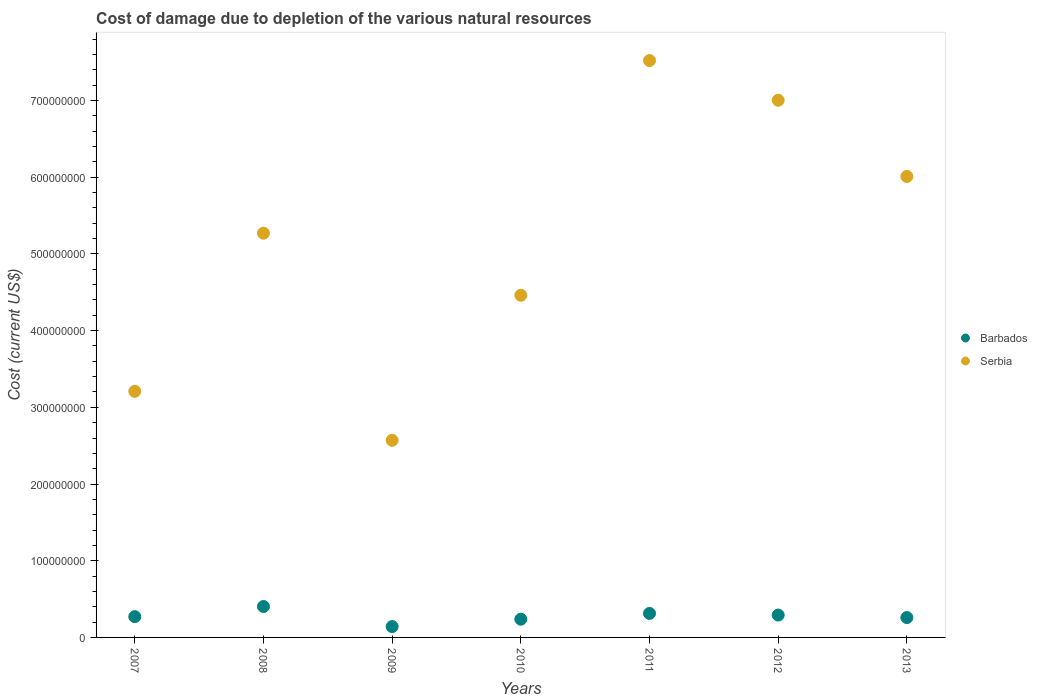How many different coloured dotlines are there?
Ensure brevity in your answer.  2. Is the number of dotlines equal to the number of legend labels?
Offer a very short reply. Yes. What is the cost of damage caused due to the depletion of various natural resources in Serbia in 2011?
Make the answer very short. 7.52e+08. Across all years, what is the maximum cost of damage caused due to the depletion of various natural resources in Serbia?
Your response must be concise. 7.52e+08. Across all years, what is the minimum cost of damage caused due to the depletion of various natural resources in Serbia?
Make the answer very short. 2.57e+08. In which year was the cost of damage caused due to the depletion of various natural resources in Barbados maximum?
Offer a very short reply. 2008. What is the total cost of damage caused due to the depletion of various natural resources in Barbados in the graph?
Your response must be concise. 1.92e+08. What is the difference between the cost of damage caused due to the depletion of various natural resources in Serbia in 2008 and that in 2009?
Give a very brief answer. 2.70e+08. What is the difference between the cost of damage caused due to the depletion of various natural resources in Serbia in 2010 and the cost of damage caused due to the depletion of various natural resources in Barbados in 2007?
Offer a very short reply. 4.19e+08. What is the average cost of damage caused due to the depletion of various natural resources in Serbia per year?
Your response must be concise. 5.15e+08. In the year 2009, what is the difference between the cost of damage caused due to the depletion of various natural resources in Barbados and cost of damage caused due to the depletion of various natural resources in Serbia?
Give a very brief answer. -2.43e+08. What is the ratio of the cost of damage caused due to the depletion of various natural resources in Barbados in 2008 to that in 2009?
Your response must be concise. 2.85. Is the cost of damage caused due to the depletion of various natural resources in Serbia in 2011 less than that in 2013?
Offer a very short reply. No. What is the difference between the highest and the second highest cost of damage caused due to the depletion of various natural resources in Serbia?
Make the answer very short. 5.17e+07. What is the difference between the highest and the lowest cost of damage caused due to the depletion of various natural resources in Serbia?
Your answer should be very brief. 4.95e+08. Is the sum of the cost of damage caused due to the depletion of various natural resources in Serbia in 2009 and 2010 greater than the maximum cost of damage caused due to the depletion of various natural resources in Barbados across all years?
Make the answer very short. Yes. Does the cost of damage caused due to the depletion of various natural resources in Barbados monotonically increase over the years?
Keep it short and to the point. No. Is the cost of damage caused due to the depletion of various natural resources in Serbia strictly less than the cost of damage caused due to the depletion of various natural resources in Barbados over the years?
Ensure brevity in your answer.  No. What is the difference between two consecutive major ticks on the Y-axis?
Offer a very short reply. 1.00e+08. Are the values on the major ticks of Y-axis written in scientific E-notation?
Make the answer very short. No. Where does the legend appear in the graph?
Keep it short and to the point. Center right. How many legend labels are there?
Keep it short and to the point. 2. What is the title of the graph?
Give a very brief answer. Cost of damage due to depletion of the various natural resources. What is the label or title of the Y-axis?
Provide a short and direct response. Cost (current US$). What is the Cost (current US$) in Barbados in 2007?
Offer a very short reply. 2.71e+07. What is the Cost (current US$) in Serbia in 2007?
Make the answer very short. 3.21e+08. What is the Cost (current US$) in Barbados in 2008?
Your answer should be compact. 4.03e+07. What is the Cost (current US$) in Serbia in 2008?
Offer a very short reply. 5.27e+08. What is the Cost (current US$) in Barbados in 2009?
Provide a short and direct response. 1.41e+07. What is the Cost (current US$) in Serbia in 2009?
Offer a terse response. 2.57e+08. What is the Cost (current US$) of Barbados in 2010?
Your answer should be very brief. 2.38e+07. What is the Cost (current US$) in Serbia in 2010?
Offer a terse response. 4.46e+08. What is the Cost (current US$) of Barbados in 2011?
Make the answer very short. 3.13e+07. What is the Cost (current US$) of Serbia in 2011?
Make the answer very short. 7.52e+08. What is the Cost (current US$) of Barbados in 2012?
Your response must be concise. 2.92e+07. What is the Cost (current US$) of Serbia in 2012?
Offer a terse response. 7.00e+08. What is the Cost (current US$) of Barbados in 2013?
Provide a succinct answer. 2.59e+07. What is the Cost (current US$) in Serbia in 2013?
Provide a short and direct response. 6.01e+08. Across all years, what is the maximum Cost (current US$) in Barbados?
Your answer should be compact. 4.03e+07. Across all years, what is the maximum Cost (current US$) in Serbia?
Keep it short and to the point. 7.52e+08. Across all years, what is the minimum Cost (current US$) of Barbados?
Your answer should be compact. 1.41e+07. Across all years, what is the minimum Cost (current US$) in Serbia?
Your response must be concise. 2.57e+08. What is the total Cost (current US$) in Barbados in the graph?
Keep it short and to the point. 1.92e+08. What is the total Cost (current US$) in Serbia in the graph?
Your answer should be very brief. 3.60e+09. What is the difference between the Cost (current US$) of Barbados in 2007 and that in 2008?
Offer a terse response. -1.32e+07. What is the difference between the Cost (current US$) in Serbia in 2007 and that in 2008?
Offer a terse response. -2.06e+08. What is the difference between the Cost (current US$) of Barbados in 2007 and that in 2009?
Your response must be concise. 1.30e+07. What is the difference between the Cost (current US$) in Serbia in 2007 and that in 2009?
Ensure brevity in your answer.  6.39e+07. What is the difference between the Cost (current US$) in Barbados in 2007 and that in 2010?
Offer a terse response. 3.32e+06. What is the difference between the Cost (current US$) of Serbia in 2007 and that in 2010?
Your response must be concise. -1.25e+08. What is the difference between the Cost (current US$) in Barbados in 2007 and that in 2011?
Provide a short and direct response. -4.22e+06. What is the difference between the Cost (current US$) of Serbia in 2007 and that in 2011?
Keep it short and to the point. -4.31e+08. What is the difference between the Cost (current US$) in Barbados in 2007 and that in 2012?
Ensure brevity in your answer.  -2.08e+06. What is the difference between the Cost (current US$) of Serbia in 2007 and that in 2012?
Your response must be concise. -3.80e+08. What is the difference between the Cost (current US$) of Barbados in 2007 and that in 2013?
Offer a very short reply. 1.18e+06. What is the difference between the Cost (current US$) of Serbia in 2007 and that in 2013?
Provide a succinct answer. -2.80e+08. What is the difference between the Cost (current US$) of Barbados in 2008 and that in 2009?
Your answer should be very brief. 2.62e+07. What is the difference between the Cost (current US$) in Serbia in 2008 and that in 2009?
Your answer should be compact. 2.70e+08. What is the difference between the Cost (current US$) in Barbados in 2008 and that in 2010?
Provide a succinct answer. 1.66e+07. What is the difference between the Cost (current US$) in Serbia in 2008 and that in 2010?
Make the answer very short. 8.09e+07. What is the difference between the Cost (current US$) of Barbados in 2008 and that in 2011?
Your response must be concise. 9.01e+06. What is the difference between the Cost (current US$) of Serbia in 2008 and that in 2011?
Your answer should be very brief. -2.25e+08. What is the difference between the Cost (current US$) of Barbados in 2008 and that in 2012?
Your answer should be compact. 1.12e+07. What is the difference between the Cost (current US$) of Serbia in 2008 and that in 2012?
Give a very brief answer. -1.73e+08. What is the difference between the Cost (current US$) in Barbados in 2008 and that in 2013?
Provide a succinct answer. 1.44e+07. What is the difference between the Cost (current US$) of Serbia in 2008 and that in 2013?
Give a very brief answer. -7.40e+07. What is the difference between the Cost (current US$) of Barbados in 2009 and that in 2010?
Make the answer very short. -9.64e+06. What is the difference between the Cost (current US$) of Serbia in 2009 and that in 2010?
Your answer should be compact. -1.89e+08. What is the difference between the Cost (current US$) of Barbados in 2009 and that in 2011?
Offer a very short reply. -1.72e+07. What is the difference between the Cost (current US$) in Serbia in 2009 and that in 2011?
Your answer should be compact. -4.95e+08. What is the difference between the Cost (current US$) of Barbados in 2009 and that in 2012?
Your response must be concise. -1.50e+07. What is the difference between the Cost (current US$) of Serbia in 2009 and that in 2012?
Your answer should be compact. -4.43e+08. What is the difference between the Cost (current US$) in Barbados in 2009 and that in 2013?
Offer a very short reply. -1.18e+07. What is the difference between the Cost (current US$) of Serbia in 2009 and that in 2013?
Your answer should be compact. -3.44e+08. What is the difference between the Cost (current US$) of Barbados in 2010 and that in 2011?
Offer a very short reply. -7.55e+06. What is the difference between the Cost (current US$) of Serbia in 2010 and that in 2011?
Provide a succinct answer. -3.06e+08. What is the difference between the Cost (current US$) of Barbados in 2010 and that in 2012?
Make the answer very short. -5.40e+06. What is the difference between the Cost (current US$) of Serbia in 2010 and that in 2012?
Provide a short and direct response. -2.54e+08. What is the difference between the Cost (current US$) in Barbados in 2010 and that in 2013?
Your answer should be very brief. -2.14e+06. What is the difference between the Cost (current US$) of Serbia in 2010 and that in 2013?
Ensure brevity in your answer.  -1.55e+08. What is the difference between the Cost (current US$) in Barbados in 2011 and that in 2012?
Your response must be concise. 2.15e+06. What is the difference between the Cost (current US$) of Serbia in 2011 and that in 2012?
Offer a very short reply. 5.17e+07. What is the difference between the Cost (current US$) in Barbados in 2011 and that in 2013?
Ensure brevity in your answer.  5.41e+06. What is the difference between the Cost (current US$) in Serbia in 2011 and that in 2013?
Offer a terse response. 1.51e+08. What is the difference between the Cost (current US$) of Barbados in 2012 and that in 2013?
Give a very brief answer. 3.26e+06. What is the difference between the Cost (current US$) of Serbia in 2012 and that in 2013?
Offer a terse response. 9.94e+07. What is the difference between the Cost (current US$) in Barbados in 2007 and the Cost (current US$) in Serbia in 2008?
Your answer should be compact. -5.00e+08. What is the difference between the Cost (current US$) in Barbados in 2007 and the Cost (current US$) in Serbia in 2009?
Keep it short and to the point. -2.30e+08. What is the difference between the Cost (current US$) in Barbados in 2007 and the Cost (current US$) in Serbia in 2010?
Offer a terse response. -4.19e+08. What is the difference between the Cost (current US$) in Barbados in 2007 and the Cost (current US$) in Serbia in 2011?
Provide a succinct answer. -7.25e+08. What is the difference between the Cost (current US$) of Barbados in 2007 and the Cost (current US$) of Serbia in 2012?
Make the answer very short. -6.73e+08. What is the difference between the Cost (current US$) in Barbados in 2007 and the Cost (current US$) in Serbia in 2013?
Give a very brief answer. -5.74e+08. What is the difference between the Cost (current US$) in Barbados in 2008 and the Cost (current US$) in Serbia in 2009?
Offer a very short reply. -2.17e+08. What is the difference between the Cost (current US$) in Barbados in 2008 and the Cost (current US$) in Serbia in 2010?
Provide a succinct answer. -4.06e+08. What is the difference between the Cost (current US$) of Barbados in 2008 and the Cost (current US$) of Serbia in 2011?
Offer a terse response. -7.12e+08. What is the difference between the Cost (current US$) in Barbados in 2008 and the Cost (current US$) in Serbia in 2012?
Ensure brevity in your answer.  -6.60e+08. What is the difference between the Cost (current US$) in Barbados in 2008 and the Cost (current US$) in Serbia in 2013?
Your answer should be very brief. -5.61e+08. What is the difference between the Cost (current US$) of Barbados in 2009 and the Cost (current US$) of Serbia in 2010?
Offer a terse response. -4.32e+08. What is the difference between the Cost (current US$) in Barbados in 2009 and the Cost (current US$) in Serbia in 2011?
Your answer should be very brief. -7.38e+08. What is the difference between the Cost (current US$) in Barbados in 2009 and the Cost (current US$) in Serbia in 2012?
Make the answer very short. -6.86e+08. What is the difference between the Cost (current US$) of Barbados in 2009 and the Cost (current US$) of Serbia in 2013?
Offer a terse response. -5.87e+08. What is the difference between the Cost (current US$) in Barbados in 2010 and the Cost (current US$) in Serbia in 2011?
Your answer should be very brief. -7.28e+08. What is the difference between the Cost (current US$) of Barbados in 2010 and the Cost (current US$) of Serbia in 2012?
Your response must be concise. -6.77e+08. What is the difference between the Cost (current US$) in Barbados in 2010 and the Cost (current US$) in Serbia in 2013?
Provide a short and direct response. -5.77e+08. What is the difference between the Cost (current US$) of Barbados in 2011 and the Cost (current US$) of Serbia in 2012?
Offer a very short reply. -6.69e+08. What is the difference between the Cost (current US$) in Barbados in 2011 and the Cost (current US$) in Serbia in 2013?
Give a very brief answer. -5.70e+08. What is the difference between the Cost (current US$) in Barbados in 2012 and the Cost (current US$) in Serbia in 2013?
Offer a very short reply. -5.72e+08. What is the average Cost (current US$) of Barbados per year?
Your response must be concise. 2.74e+07. What is the average Cost (current US$) of Serbia per year?
Keep it short and to the point. 5.15e+08. In the year 2007, what is the difference between the Cost (current US$) in Barbados and Cost (current US$) in Serbia?
Your response must be concise. -2.94e+08. In the year 2008, what is the difference between the Cost (current US$) of Barbados and Cost (current US$) of Serbia?
Make the answer very short. -4.87e+08. In the year 2009, what is the difference between the Cost (current US$) in Barbados and Cost (current US$) in Serbia?
Provide a succinct answer. -2.43e+08. In the year 2010, what is the difference between the Cost (current US$) of Barbados and Cost (current US$) of Serbia?
Your answer should be very brief. -4.22e+08. In the year 2011, what is the difference between the Cost (current US$) of Barbados and Cost (current US$) of Serbia?
Your answer should be very brief. -7.21e+08. In the year 2012, what is the difference between the Cost (current US$) of Barbados and Cost (current US$) of Serbia?
Your answer should be compact. -6.71e+08. In the year 2013, what is the difference between the Cost (current US$) in Barbados and Cost (current US$) in Serbia?
Offer a very short reply. -5.75e+08. What is the ratio of the Cost (current US$) of Barbados in 2007 to that in 2008?
Your answer should be very brief. 0.67. What is the ratio of the Cost (current US$) of Serbia in 2007 to that in 2008?
Ensure brevity in your answer.  0.61. What is the ratio of the Cost (current US$) of Barbados in 2007 to that in 2009?
Keep it short and to the point. 1.92. What is the ratio of the Cost (current US$) of Serbia in 2007 to that in 2009?
Give a very brief answer. 1.25. What is the ratio of the Cost (current US$) of Barbados in 2007 to that in 2010?
Ensure brevity in your answer.  1.14. What is the ratio of the Cost (current US$) of Serbia in 2007 to that in 2010?
Your answer should be very brief. 0.72. What is the ratio of the Cost (current US$) of Barbados in 2007 to that in 2011?
Make the answer very short. 0.87. What is the ratio of the Cost (current US$) in Serbia in 2007 to that in 2011?
Offer a terse response. 0.43. What is the ratio of the Cost (current US$) of Barbados in 2007 to that in 2012?
Make the answer very short. 0.93. What is the ratio of the Cost (current US$) of Serbia in 2007 to that in 2012?
Provide a short and direct response. 0.46. What is the ratio of the Cost (current US$) in Barbados in 2007 to that in 2013?
Your answer should be very brief. 1.05. What is the ratio of the Cost (current US$) in Serbia in 2007 to that in 2013?
Provide a succinct answer. 0.53. What is the ratio of the Cost (current US$) in Barbados in 2008 to that in 2009?
Ensure brevity in your answer.  2.85. What is the ratio of the Cost (current US$) in Serbia in 2008 to that in 2009?
Your answer should be compact. 2.05. What is the ratio of the Cost (current US$) of Barbados in 2008 to that in 2010?
Give a very brief answer. 1.7. What is the ratio of the Cost (current US$) in Serbia in 2008 to that in 2010?
Offer a terse response. 1.18. What is the ratio of the Cost (current US$) in Barbados in 2008 to that in 2011?
Provide a short and direct response. 1.29. What is the ratio of the Cost (current US$) in Serbia in 2008 to that in 2011?
Ensure brevity in your answer.  0.7. What is the ratio of the Cost (current US$) of Barbados in 2008 to that in 2012?
Your answer should be very brief. 1.38. What is the ratio of the Cost (current US$) in Serbia in 2008 to that in 2012?
Offer a very short reply. 0.75. What is the ratio of the Cost (current US$) of Barbados in 2008 to that in 2013?
Give a very brief answer. 1.56. What is the ratio of the Cost (current US$) in Serbia in 2008 to that in 2013?
Ensure brevity in your answer.  0.88. What is the ratio of the Cost (current US$) in Barbados in 2009 to that in 2010?
Offer a terse response. 0.59. What is the ratio of the Cost (current US$) of Serbia in 2009 to that in 2010?
Offer a terse response. 0.58. What is the ratio of the Cost (current US$) of Barbados in 2009 to that in 2011?
Provide a succinct answer. 0.45. What is the ratio of the Cost (current US$) in Serbia in 2009 to that in 2011?
Keep it short and to the point. 0.34. What is the ratio of the Cost (current US$) in Barbados in 2009 to that in 2012?
Offer a very short reply. 0.48. What is the ratio of the Cost (current US$) of Serbia in 2009 to that in 2012?
Keep it short and to the point. 0.37. What is the ratio of the Cost (current US$) in Barbados in 2009 to that in 2013?
Ensure brevity in your answer.  0.55. What is the ratio of the Cost (current US$) in Serbia in 2009 to that in 2013?
Your response must be concise. 0.43. What is the ratio of the Cost (current US$) of Barbados in 2010 to that in 2011?
Make the answer very short. 0.76. What is the ratio of the Cost (current US$) in Serbia in 2010 to that in 2011?
Provide a succinct answer. 0.59. What is the ratio of the Cost (current US$) in Barbados in 2010 to that in 2012?
Keep it short and to the point. 0.81. What is the ratio of the Cost (current US$) in Serbia in 2010 to that in 2012?
Give a very brief answer. 0.64. What is the ratio of the Cost (current US$) in Barbados in 2010 to that in 2013?
Offer a very short reply. 0.92. What is the ratio of the Cost (current US$) in Serbia in 2010 to that in 2013?
Provide a succinct answer. 0.74. What is the ratio of the Cost (current US$) in Barbados in 2011 to that in 2012?
Keep it short and to the point. 1.07. What is the ratio of the Cost (current US$) in Serbia in 2011 to that in 2012?
Your answer should be compact. 1.07. What is the ratio of the Cost (current US$) in Barbados in 2011 to that in 2013?
Your response must be concise. 1.21. What is the ratio of the Cost (current US$) of Serbia in 2011 to that in 2013?
Make the answer very short. 1.25. What is the ratio of the Cost (current US$) in Barbados in 2012 to that in 2013?
Ensure brevity in your answer.  1.13. What is the ratio of the Cost (current US$) of Serbia in 2012 to that in 2013?
Provide a short and direct response. 1.17. What is the difference between the highest and the second highest Cost (current US$) of Barbados?
Your response must be concise. 9.01e+06. What is the difference between the highest and the second highest Cost (current US$) in Serbia?
Provide a short and direct response. 5.17e+07. What is the difference between the highest and the lowest Cost (current US$) in Barbados?
Provide a short and direct response. 2.62e+07. What is the difference between the highest and the lowest Cost (current US$) in Serbia?
Keep it short and to the point. 4.95e+08. 